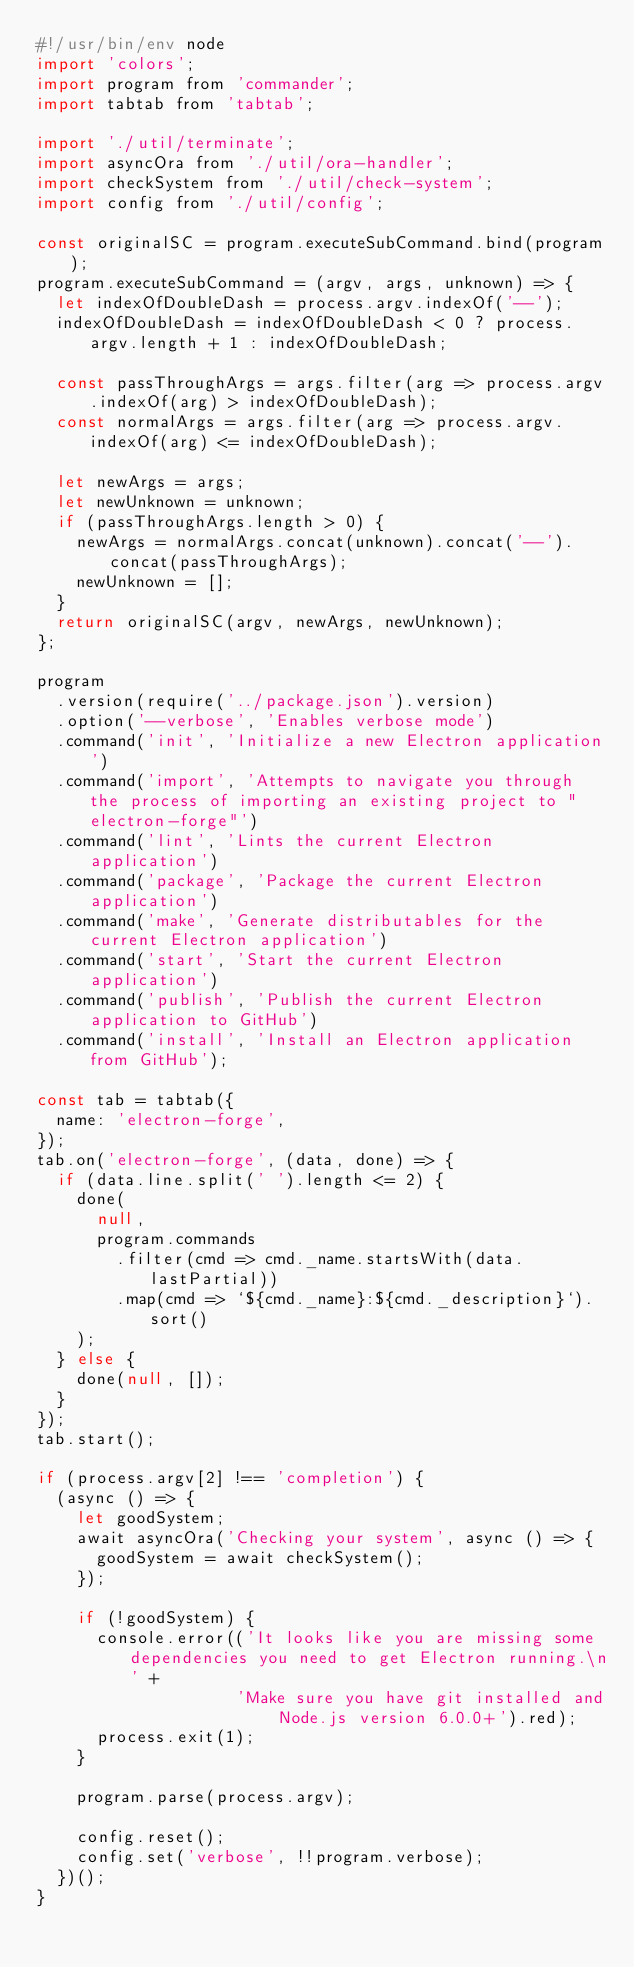Convert code to text. <code><loc_0><loc_0><loc_500><loc_500><_JavaScript_>#!/usr/bin/env node
import 'colors';
import program from 'commander';
import tabtab from 'tabtab';

import './util/terminate';
import asyncOra from './util/ora-handler';
import checkSystem from './util/check-system';
import config from './util/config';

const originalSC = program.executeSubCommand.bind(program);
program.executeSubCommand = (argv, args, unknown) => {
  let indexOfDoubleDash = process.argv.indexOf('--');
  indexOfDoubleDash = indexOfDoubleDash < 0 ? process.argv.length + 1 : indexOfDoubleDash;

  const passThroughArgs = args.filter(arg => process.argv.indexOf(arg) > indexOfDoubleDash);
  const normalArgs = args.filter(arg => process.argv.indexOf(arg) <= indexOfDoubleDash);

  let newArgs = args;
  let newUnknown = unknown;
  if (passThroughArgs.length > 0) {
    newArgs = normalArgs.concat(unknown).concat('--').concat(passThroughArgs);
    newUnknown = [];
  }
  return originalSC(argv, newArgs, newUnknown);
};

program
  .version(require('../package.json').version)
  .option('--verbose', 'Enables verbose mode')
  .command('init', 'Initialize a new Electron application')
  .command('import', 'Attempts to navigate you through the process of importing an existing project to "electron-forge"')
  .command('lint', 'Lints the current Electron application')
  .command('package', 'Package the current Electron application')
  .command('make', 'Generate distributables for the current Electron application')
  .command('start', 'Start the current Electron application')
  .command('publish', 'Publish the current Electron application to GitHub')
  .command('install', 'Install an Electron application from GitHub');

const tab = tabtab({
  name: 'electron-forge',
});
tab.on('electron-forge', (data, done) => {
  if (data.line.split(' ').length <= 2) {
    done(
      null,
      program.commands
        .filter(cmd => cmd._name.startsWith(data.lastPartial))
        .map(cmd => `${cmd._name}:${cmd._description}`).sort()
    );
  } else {
    done(null, []);
  }
});
tab.start();

if (process.argv[2] !== 'completion') {
  (async () => {
    let goodSystem;
    await asyncOra('Checking your system', async () => {
      goodSystem = await checkSystem();
    });

    if (!goodSystem) {
      console.error(('It looks like you are missing some dependencies you need to get Electron running.\n' +
                    'Make sure you have git installed and Node.js version 6.0.0+').red);
      process.exit(1);
    }

    program.parse(process.argv);

    config.reset();
    config.set('verbose', !!program.verbose);
  })();
}
</code> 